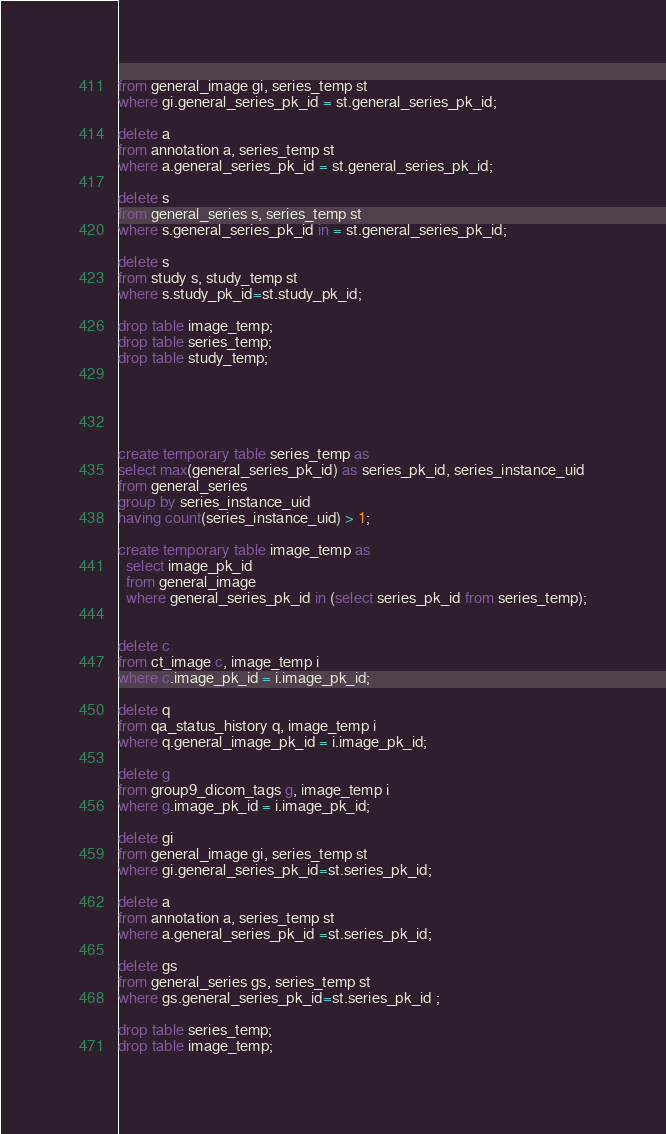<code> <loc_0><loc_0><loc_500><loc_500><_SQL_>from general_image gi, series_temp st
where gi.general_series_pk_id = st.general_series_pk_id;

delete a
from annotation a, series_temp st
where a.general_series_pk_id = st.general_series_pk_id;

delete s
from general_series s, series_temp st
where s.general_series_pk_id in = st.general_series_pk_id;

delete s 
from study s, study_temp st
where s.study_pk_id=st.study_pk_id;

drop table image_temp;
drop table series_temp;
drop table study_temp;





create temporary table series_temp as 
select max(general_series_pk_id) as series_pk_id, series_instance_uid
from general_series
group by series_instance_uid
having count(series_instance_uid) > 1;

create temporary table image_temp as 
  select image_pk_id 
  from general_image 
  where general_series_pk_id in (select series_pk_id from series_temp);


delete c
from ct_image c, image_temp i
where c.image_pk_id = i.image_pk_id;

delete q
from qa_status_history q, image_temp i
where q.general_image_pk_id = i.image_pk_id;

delete g
from group9_dicom_tags g, image_temp i
where g.image_pk_id = i.image_pk_id;

delete gi
from general_image gi, series_temp st
where gi.general_series_pk_id=st.series_pk_id;

delete a
from annotation a, series_temp st  
where a.general_series_pk_id =st.series_pk_id;

delete gs
from general_series gs, series_temp st
where gs.general_series_pk_id=st.series_pk_id ;

drop table series_temp;
drop table image_temp;
</code> 